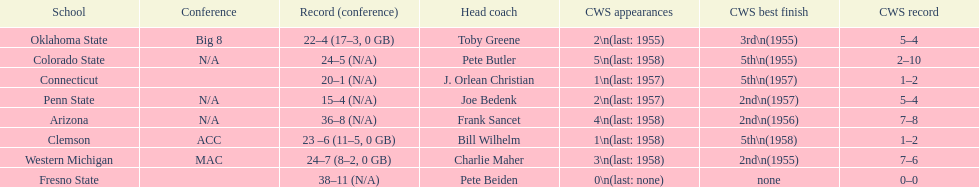Oklahoma state and penn state both have how many cws appearances? 2. Write the full table. {'header': ['School', 'Conference', 'Record (conference)', 'Head coach', 'CWS appearances', 'CWS best finish', 'CWS record'], 'rows': [['Oklahoma State', 'Big 8', '22–4 (17–3, 0 GB)', 'Toby Greene', '2\\n(last: 1955)', '3rd\\n(1955)', '5–4'], ['Colorado State', 'N/A', '24–5 (N/A)', 'Pete Butler', '5\\n(last: 1958)', '5th\\n(1955)', '2–10'], ['Connecticut', '', '20–1 (N/A)', 'J. Orlean Christian', '1\\n(last: 1957)', '5th\\n(1957)', '1–2'], ['Penn State', 'N/A', '15–4 (N/A)', 'Joe Bedenk', '2\\n(last: 1957)', '2nd\\n(1957)', '5–4'], ['Arizona', 'N/A', '36–8 (N/A)', 'Frank Sancet', '4\\n(last: 1958)', '2nd\\n(1956)', '7–8'], ['Clemson', 'ACC', '23 –6 (11–5, 0 GB)', 'Bill Wilhelm', '1\\n(last: 1958)', '5th\\n(1958)', '1–2'], ['Western Michigan', 'MAC', '24–7 (8–2, 0 GB)', 'Charlie Maher', '3\\n(last: 1958)', '2nd\\n(1955)', '7–6'], ['Fresno State', '', '38–11 (N/A)', 'Pete Beiden', '0\\n(last: none)', 'none', '0–0']]} 